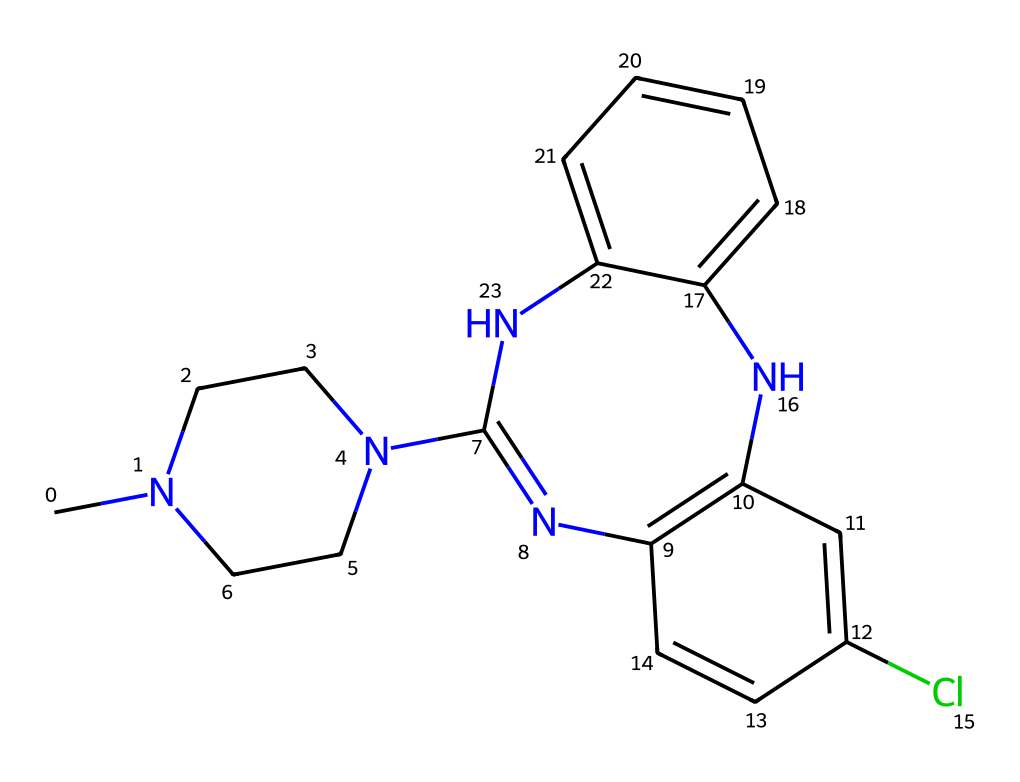What is the total number of nitrogen atoms in this chemical? By examining the SMILES representation, we can identify the nitrogen atoms present. The representation contains "N" four times, indicating the presence of four nitrogen atoms in total.
Answer: four How many carbon atoms are present in this structure? By counting the carbon atoms represented in the SMILES, each "C" and "C" in the cyclic structure counts, totaling to 18 carbon atoms in the entire structure.
Answer: eighteen What type of bonds are primarily found in this chemical? Analyzing the structure, we can see that the connections between carbon and nitrogen atoms are primarily single and double bonds, indicating the presence of covalent bonds.
Answer: covalent Which part of the structure is responsible for its antipsychotic activity? The tricyclic structure containing both nitrogen and carbon features is characteristic of antipsychotic medications, indicating that the fused ring systems contribute to the binding interactions with the receptors in the brain.
Answer: fused ring systems What is the molecular formula for clozapine based on its structure? By determining the number of each type of atom from the SMILES: C=18, H=19, Cl=1, N=4 gives the molecular formula C18H19ClN4.
Answer: C18H19ClN4 Is there a halogen present in this chemical? Yes, the presence of 'Cl' in the SMILES indicates there is a chlorine atom, which is a halogen.
Answer: yes 